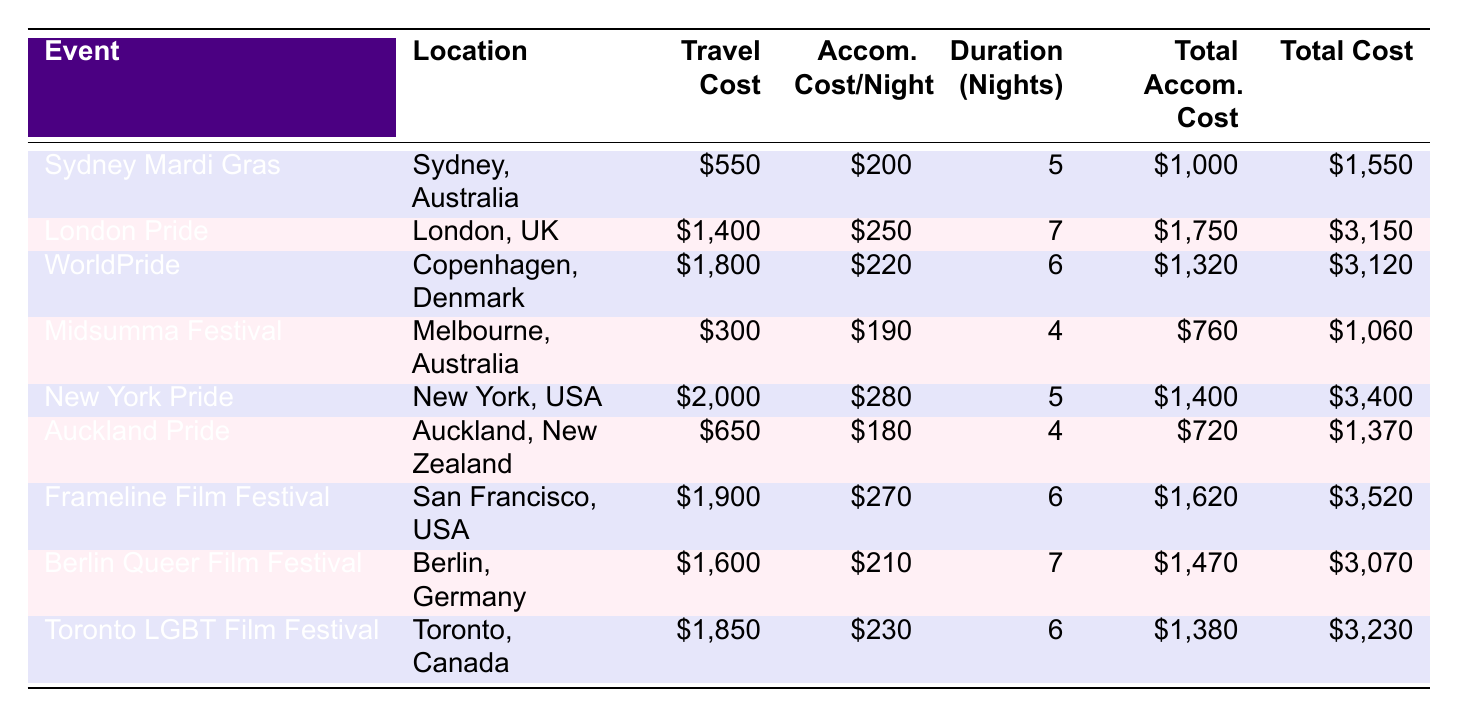What is the total cost for attending the Sydney Mardi Gras? The total cost for attending the Sydney Mardi Gras is listed in the "Total Cost" column for that event, which shows \$1,550.
Answer: 1550 What is the accommodation cost per night for the London Pride event? The accommodation cost per night for the London Pride event is found in the "Accom. Cost/Night" column for that event, which is \$250.
Answer: 250 How much more expensive is it to attend New York Pride compared to Midsumma Festival? The total cost for New York Pride is \$3,400 and for Midsumma Festival, it is \$1,060. The difference is calculated as \$3,400 - \$1,060 = \$2,340.
Answer: 2340 Is the total accommodation cost for WorldPride higher than that for Toronto LGBT Film Festival? The total accommodation cost for WorldPride is \$1,320 and for Toronto LGBT Film Festival, it is \$1,380. Since \$1,320 is less than \$1,380, the answer is no.
Answer: No What is the average travel cost for all events listed in the table? To find the average travel cost, add all the travel costs: \$550 + \$1,400 + \$1,800 + \$300 + \$2,000 + \$650 + \$1,900 + \$1,600 + \$1,850 = \$11,050. Then divide by the number of events (9): \$11,050 / 9 ≈ \$1,228.89, which rounds to approximately \$1,229.
Answer: 1229 How many events have a total cost greater than \$3,000? By checking the "Total Cost" column, the events London Pride, New York Pride, Frameline Film Festival, Berlin Queer Film Festival, and Toronto LGBT Film Festival have total costs greater than \$3,000. There are 5 such events.
Answer: 5 Which event has the lowest total cost? "Midsumma Festival" has the lowest total cost, which is listed as \$1,060 in the "Total Cost" column.
Answer: 1060 What is the total spending on accommodation across all events? To find the total spending on accommodation, sum all the total accommodation costs: \$1,000 + \$1,750 + \$1,320 + \$760 + \$1,400 + \$720 + \$1,620 + \$1,470 + \$1,380 = \$10,520.
Answer: 10520 Are there more events held in Australia than in the USA? The table indicates that events held in Australia are Sydney Mardi Gras and Midsumma Festival, totaling 2 events. Events in the USA are New York Pride and Frameline Film Festival, totaling 2 events. Since both have the same number, the answer is no.
Answer: No 